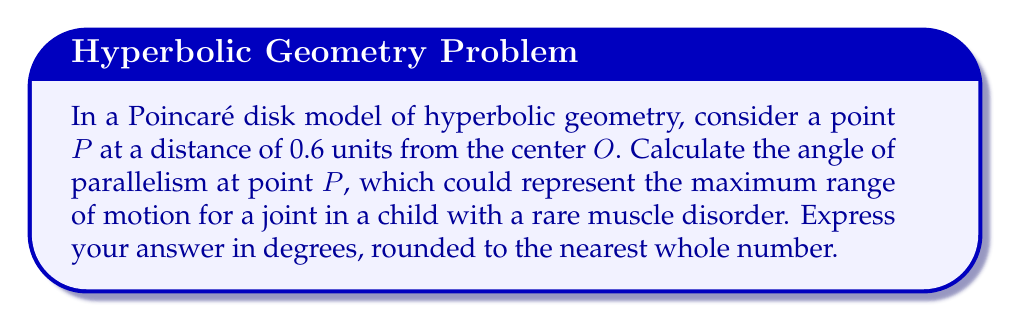Teach me how to tackle this problem. To solve this problem, we'll follow these steps:

1) In the Poincaré disk model, the angle of parallelism $\Pi(d)$ for a point at distance $d$ from the center is given by the formula:

   $$\Pi(d) = 2 \arctan(e^{-d})$$

2) We're given that the distance $d = 0.6$ units.

3) Let's substitute this into our formula:

   $$\Pi(0.6) = 2 \arctan(e^{-0.6})$$

4) Now, let's calculate $e^{-0.6}$:
   
   $$e^{-0.6} \approx 0.5488$$

5) Next, we calculate $\arctan(0.5488)$:
   
   $$\arctan(0.5488) \approx 0.5012 \text{ radians}$$

6) Now, we multiply this by 2:
   
   $$2 * 0.5012 \approx 1.0024 \text{ radians}$$

7) To convert radians to degrees, we multiply by $\frac{180}{\pi}$:

   $$1.0024 * \frac{180}{\pi} \approx 57.46 \text{ degrees}$$

8) Rounding to the nearest whole number:

   $$57.46 \approx 57 \text{ degrees}$$

This angle represents the maximum range of motion for a joint at this position in the hyperbolic model, which could be used to study potential improvements in mobility for a child with a rare muscle disorder.
Answer: 57° 